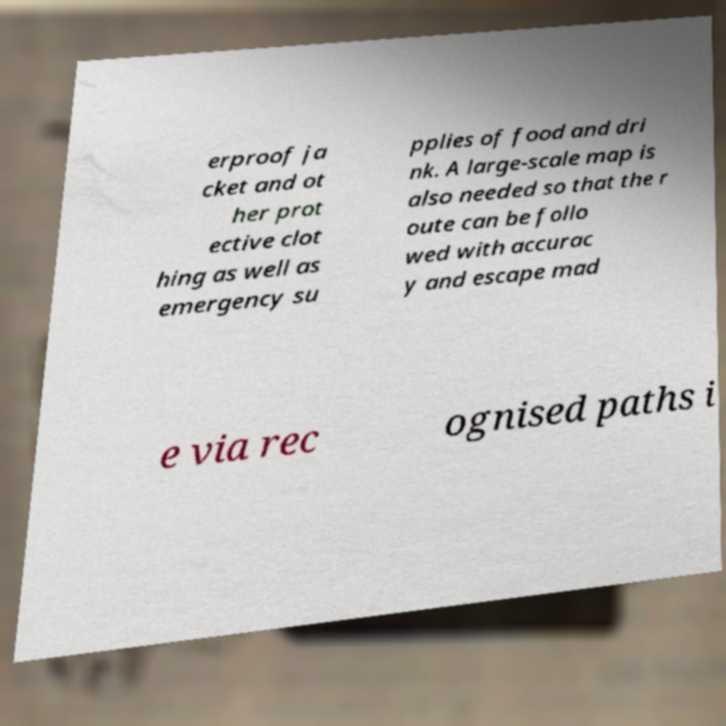For documentation purposes, I need the text within this image transcribed. Could you provide that? erproof ja cket and ot her prot ective clot hing as well as emergency su pplies of food and dri nk. A large-scale map is also needed so that the r oute can be follo wed with accurac y and escape mad e via rec ognised paths i 